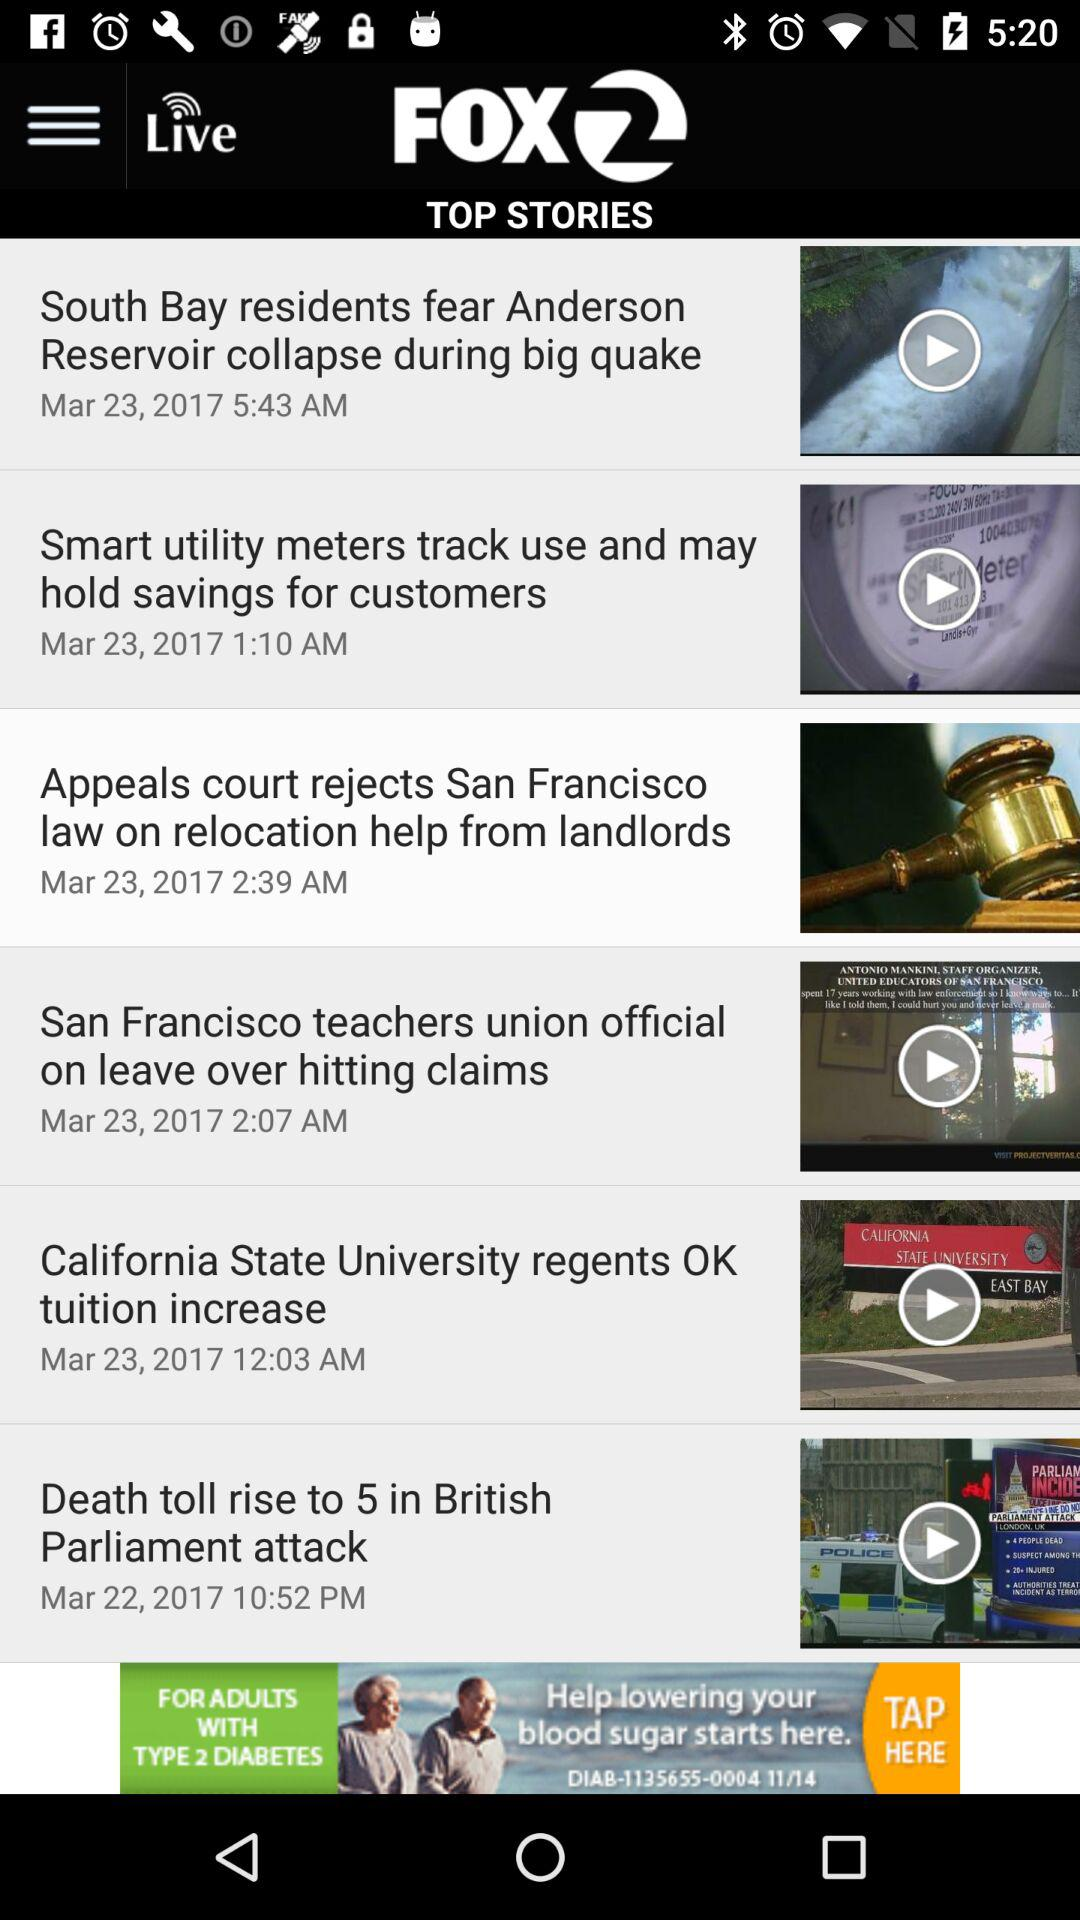What is the posted time of the story "Death toll rises to 5 in British Parliament attack"? The posted time of the story "Death toll rises to 5 in British Parliament attack" is 10:52 p.m. 